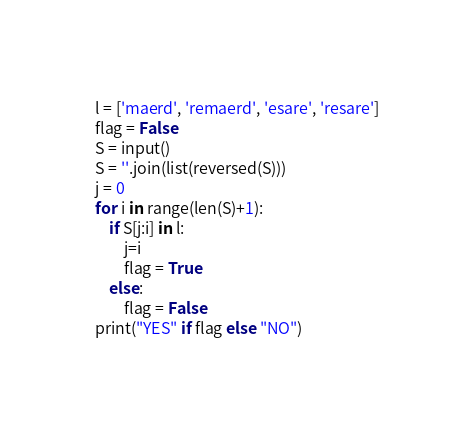Convert code to text. <code><loc_0><loc_0><loc_500><loc_500><_Python_>l = ['maerd', 'remaerd', 'esare', 'resare']
flag = False
S = input()
S = ''.join(list(reversed(S)))
j = 0
for i in range(len(S)+1):
    if S[j:i] in l:
        j=i
        flag = True
    else:
        flag = False
print("YES" if flag else "NO")</code> 